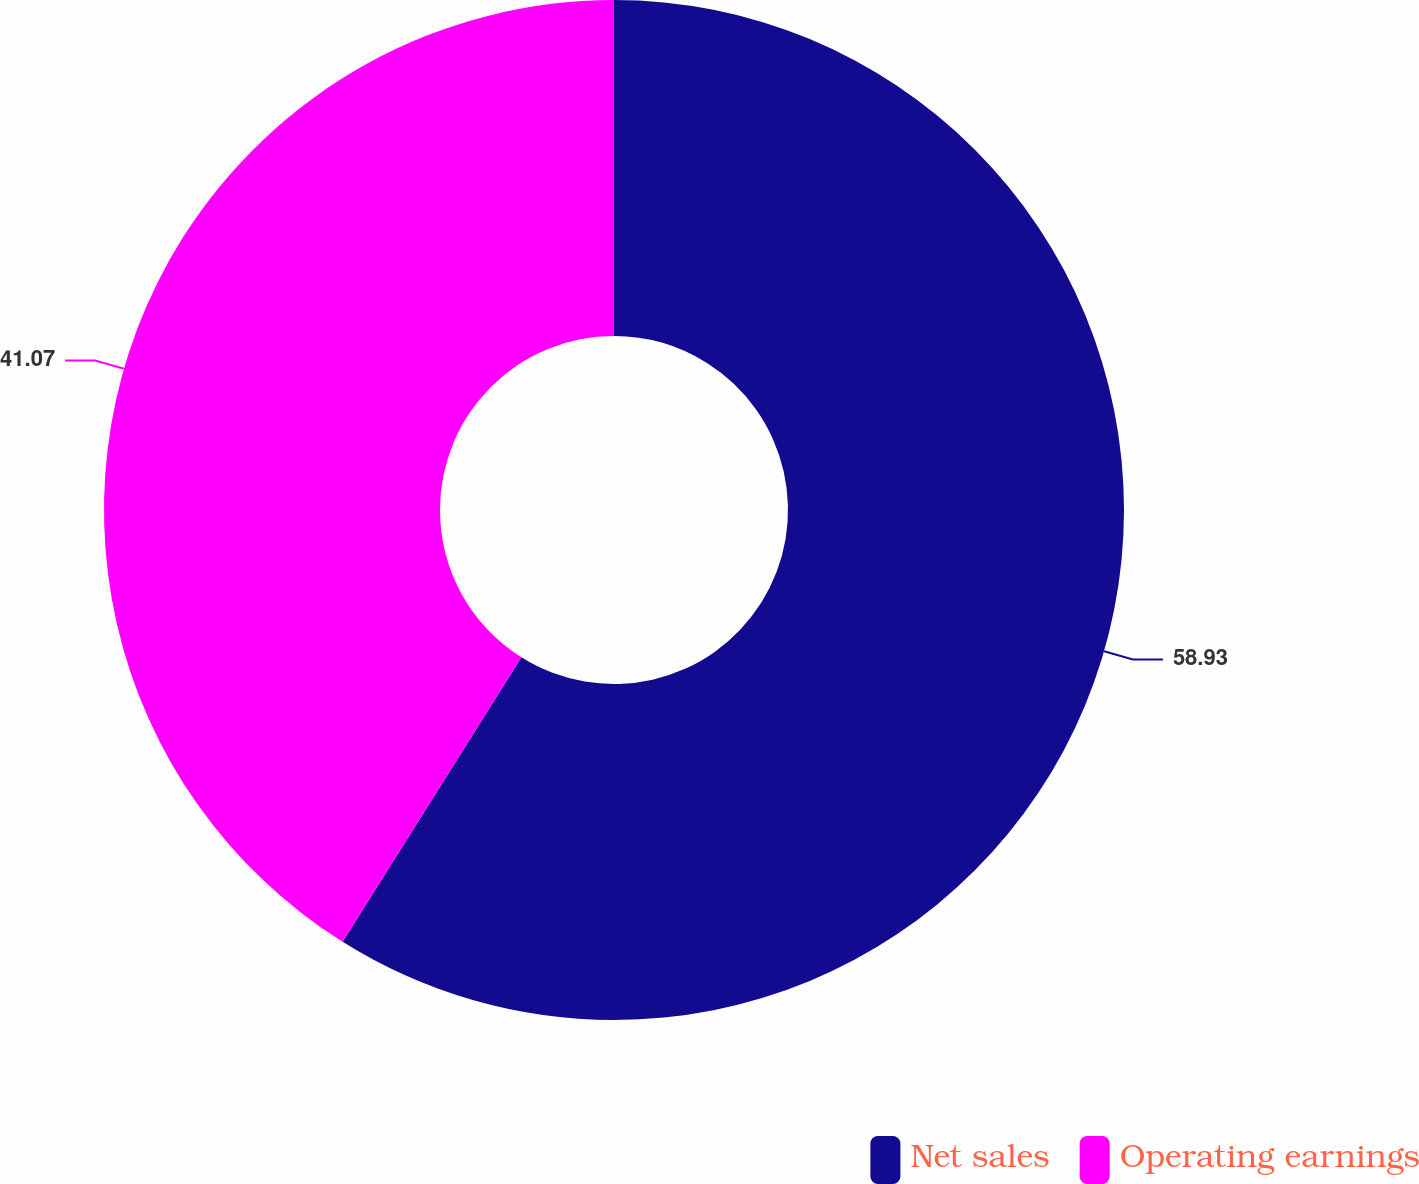Convert chart. <chart><loc_0><loc_0><loc_500><loc_500><pie_chart><fcel>Net sales<fcel>Operating earnings<nl><fcel>58.93%<fcel>41.07%<nl></chart> 